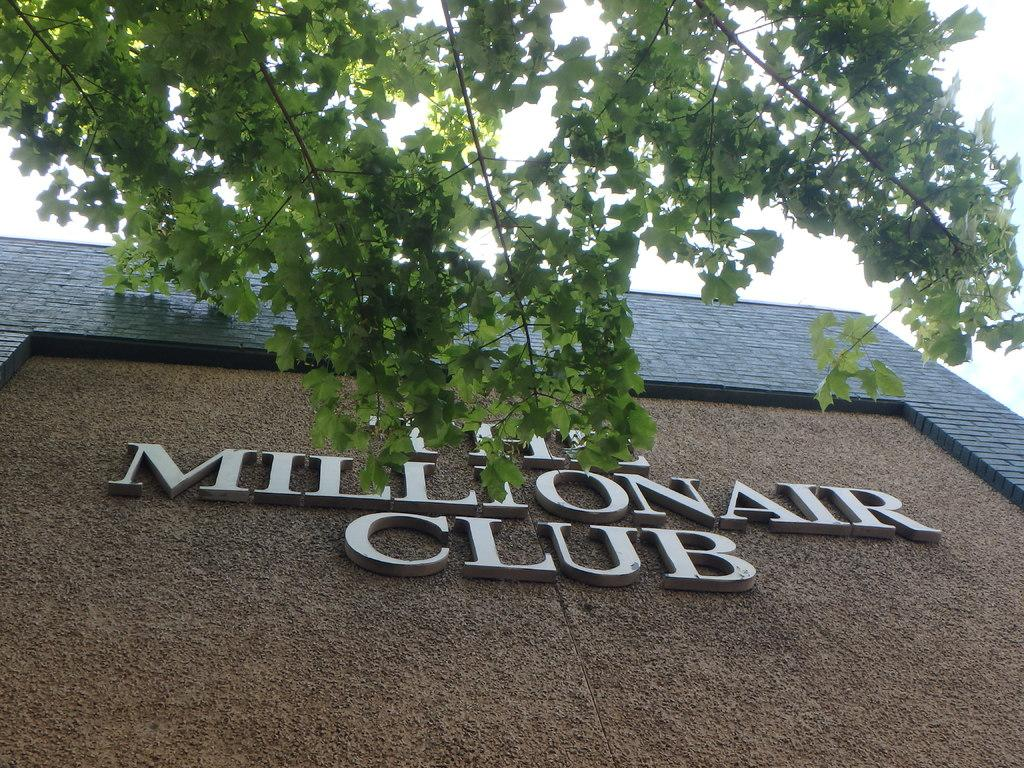What is the main feature of the image's center? The center of the image contains the sky. What type of structure is present in the image? There is a building in the image. What is a notable feature of the building? The building has a wall. What other object is present in the image? There is a tree in the image. What information is displayed on the building? The building has the text "The Millionaire Club" written on it. How many beds are visible in the image? There are no beds present in the image. What type of cloth is draped over the crate in the image? There is no crate or cloth present in the image. 